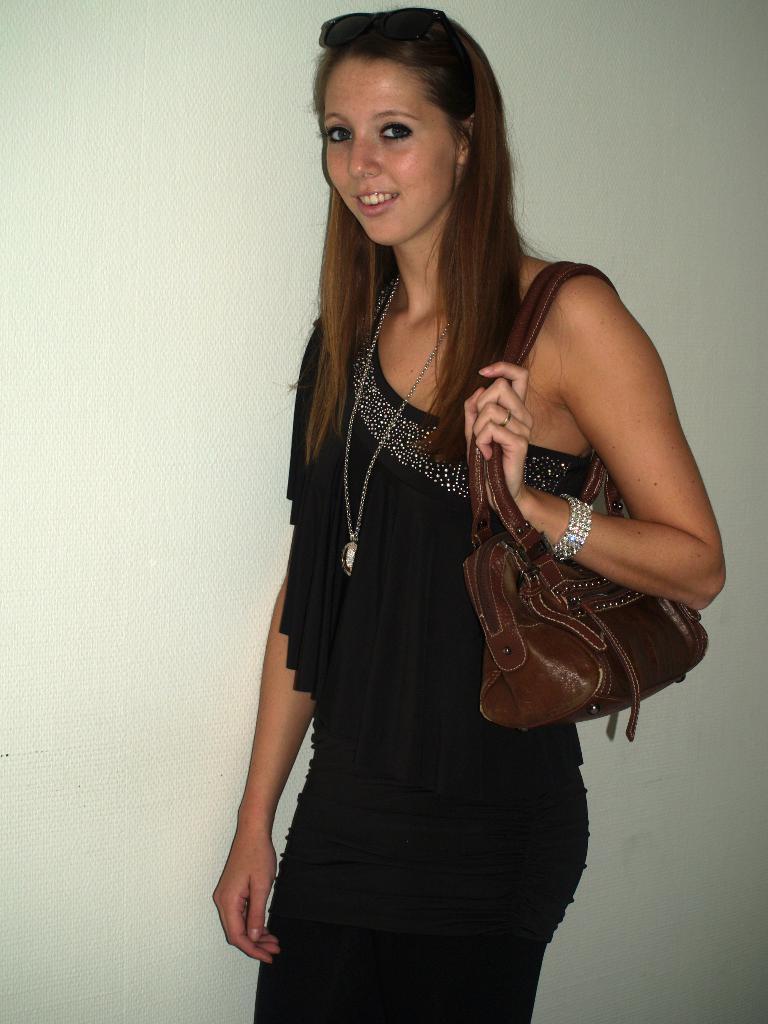How would you summarize this image in a sentence or two? In this picture we can see a woman is standing and smiling, she is carrying a bag, in the background there is a wall. 